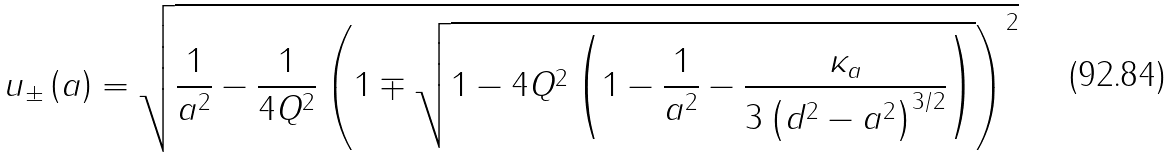Convert formula to latex. <formula><loc_0><loc_0><loc_500><loc_500>u _ { \pm } \left ( a \right ) = \sqrt { \frac { 1 } { a ^ { 2 } } - \frac { 1 } { 4 Q ^ { 2 } } \left ( 1 \mp \sqrt { 1 - 4 Q ^ { 2 } \left ( 1 - \frac { 1 } { a ^ { 2 } } - \frac { \kappa _ { a } } { 3 \left ( d ^ { 2 } - a ^ { 2 } \right ) ^ { 3 / 2 } } \right ) } \right ) ^ { 2 } }</formula> 